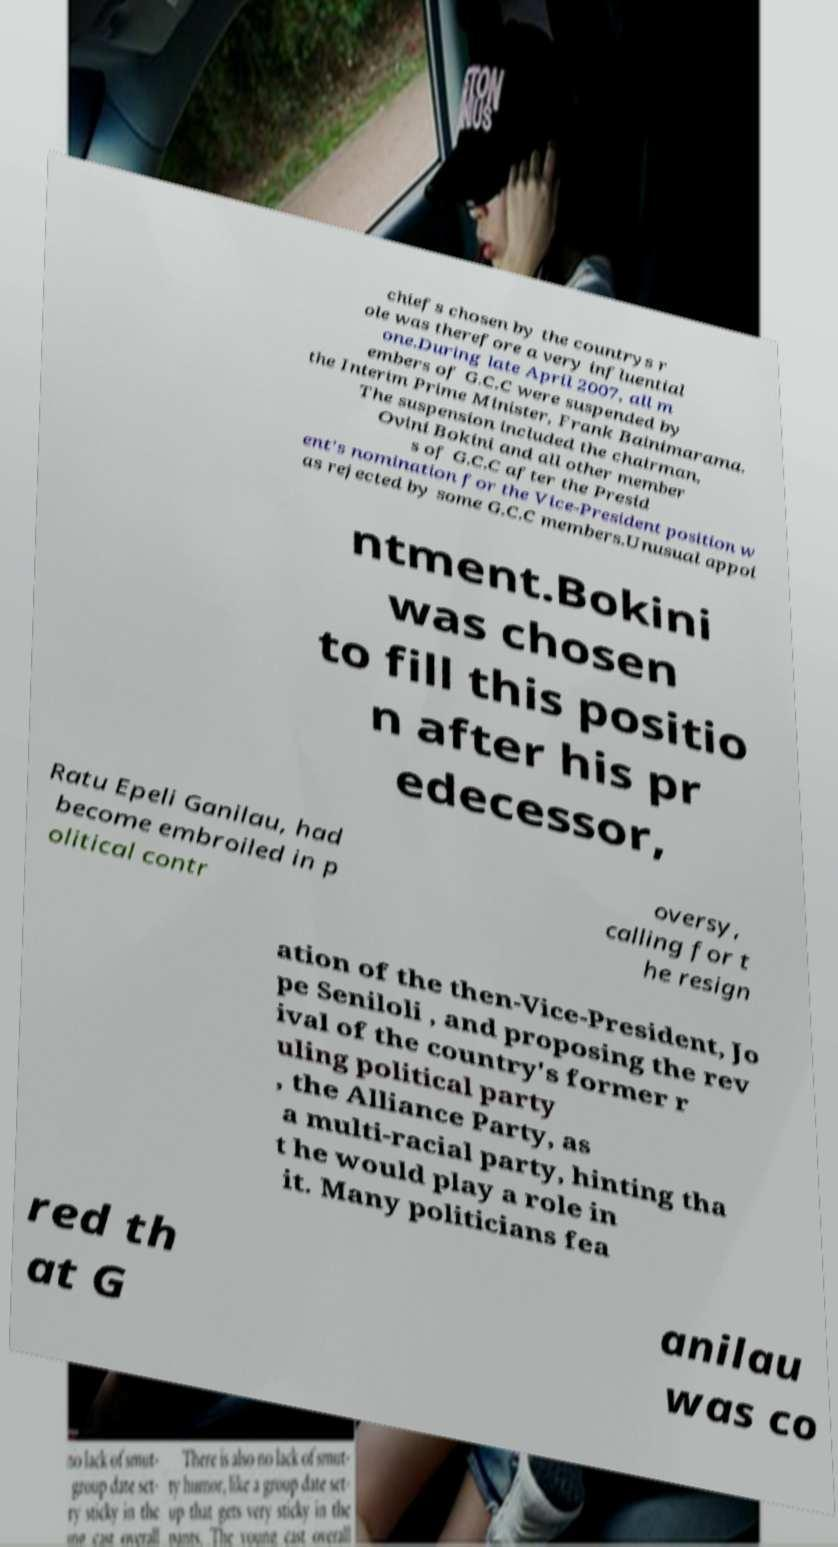Could you extract and type out the text from this image? chiefs chosen by the countrys r ole was therefore a very influential one.During late April 2007, all m embers of G.C.C were suspended by the Interim Prime Minister, Frank Bainimarama. The suspension included the chairman, Ovini Bokini and all other member s of G.C.C after the Presid ent's nomination for the Vice-President position w as rejected by some G.C.C members.Unusual appoi ntment.Bokini was chosen to fill this positio n after his pr edecessor, Ratu Epeli Ganilau, had become embroiled in p olitical contr oversy, calling for t he resign ation of the then-Vice-President, Jo pe Seniloli , and proposing the rev ival of the country's former r uling political party , the Alliance Party, as a multi-racial party, hinting tha t he would play a role in it. Many politicians fea red th at G anilau was co 